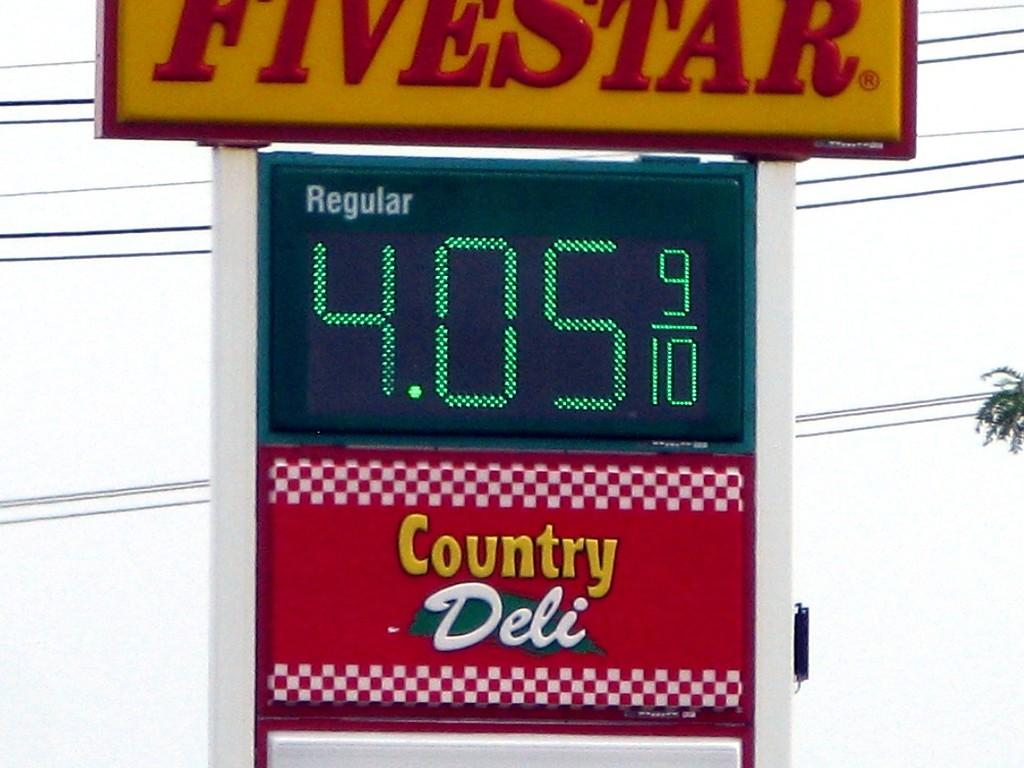<image>
Offer a succinct explanation of the picture presented. The Fivestar gas station is selling regular gas for 4.05. 